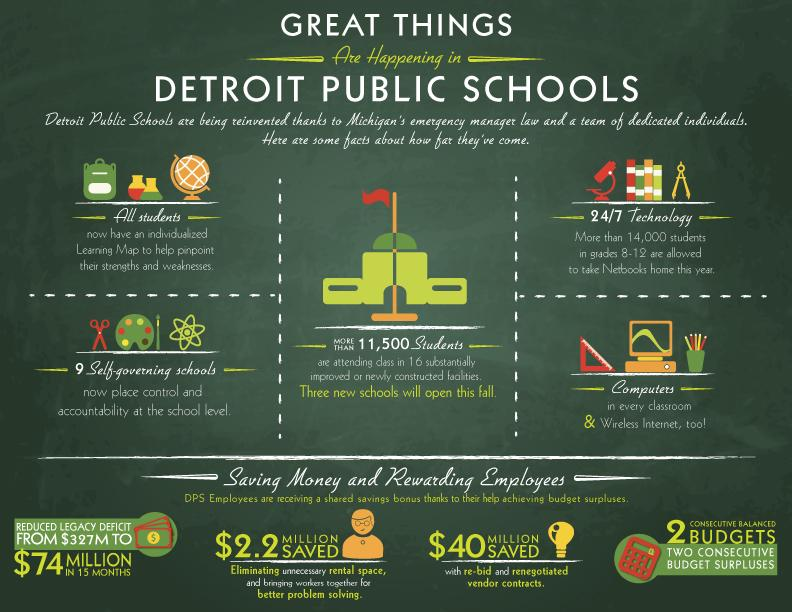Highlight a few significant elements in this photo. The decrease in settlement debt amount within one and a half year is approximately 253 million. Recently built blocks are currently accommodating a total of 11,500 students. The study rooms of Detroit Public Schools now offer state-of-the-art facilities, including computers and wireless internet, to enhance student learning and engagement. Learning Maps is a new technology designed to track the progress of children in their educational journey. 